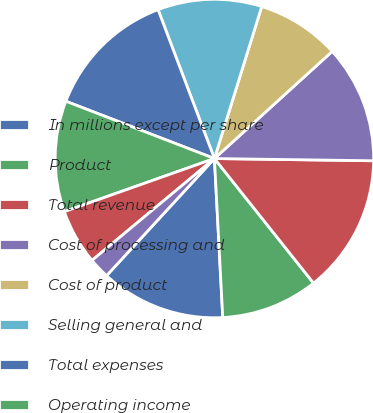Convert chart. <chart><loc_0><loc_0><loc_500><loc_500><pie_chart><fcel>In millions except per share<fcel>Product<fcel>Total revenue<fcel>Cost of processing and<fcel>Cost of product<fcel>Selling general and<fcel>Total expenses<fcel>Operating income<fcel>Interest expense<fcel>Interest and investment income<nl><fcel>12.68%<fcel>9.86%<fcel>14.08%<fcel>11.97%<fcel>8.45%<fcel>10.56%<fcel>13.38%<fcel>11.27%<fcel>5.63%<fcel>2.11%<nl></chart> 